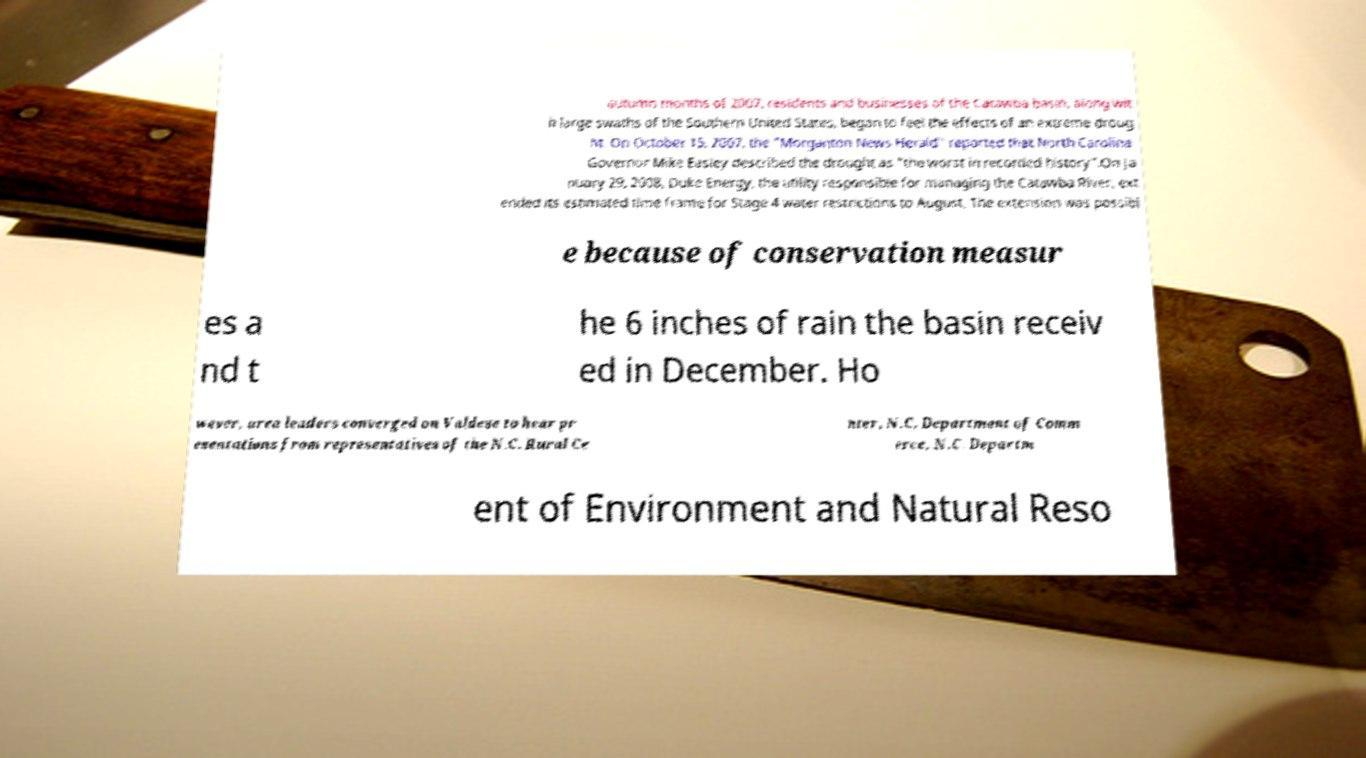For documentation purposes, I need the text within this image transcribed. Could you provide that? autumn months of 2007, residents and businesses of the Catawba basin, along wit h large swaths of the Southern United States, began to feel the effects of an extreme droug ht. On October 15, 2007, the "Morganton News Herald" reported that North Carolina Governor Mike Easley described the drought as "the worst in recorded history".On Ja nuary 29, 2008, Duke Energy, the utility responsible for managing the Catawba River, ext ended its estimated time frame for Stage 4 water restrictions to August. The extension was possibl e because of conservation measur es a nd t he 6 inches of rain the basin receiv ed in December. Ho wever, area leaders converged on Valdese to hear pr esentations from representatives of the N.C. Rural Ce nter, N.C. Department of Comm erce, N.C. Departm ent of Environment and Natural Reso 